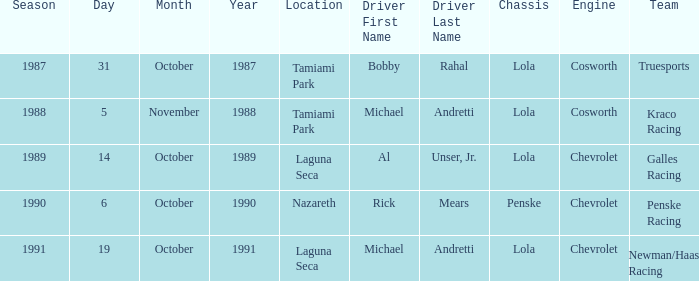Would you mind parsing the complete table? {'header': ['Season', 'Day', 'Month', 'Year', 'Location', 'Driver First Name', 'Driver Last Name', 'Chassis', 'Engine', 'Team'], 'rows': [['1987', '31', 'October', '1987', 'Tamiami Park', 'Bobby', 'Rahal', 'Lola', 'Cosworth', 'Truesports'], ['1988', '5', 'November', '1988', 'Tamiami Park', 'Michael', 'Andretti', 'Lola', 'Cosworth', 'Kraco Racing'], ['1989', '14', 'October', '1989', 'Laguna Seca', 'Al', 'Unser, Jr.', 'Lola', 'Chevrolet', 'Galles Racing'], ['1990', '6', 'October', '1990', 'Nazareth', 'Rick', 'Mears', 'Penske', 'Chevrolet', 'Penske Racing'], ['1991', '19', 'October', '1991', 'Laguna Seca', 'Michael', 'Andretti', 'Lola', 'Chevrolet', 'Newman/Haas Racing']]} Which team was involved in the race on the 19th of october? Newman/Haas Racing. 